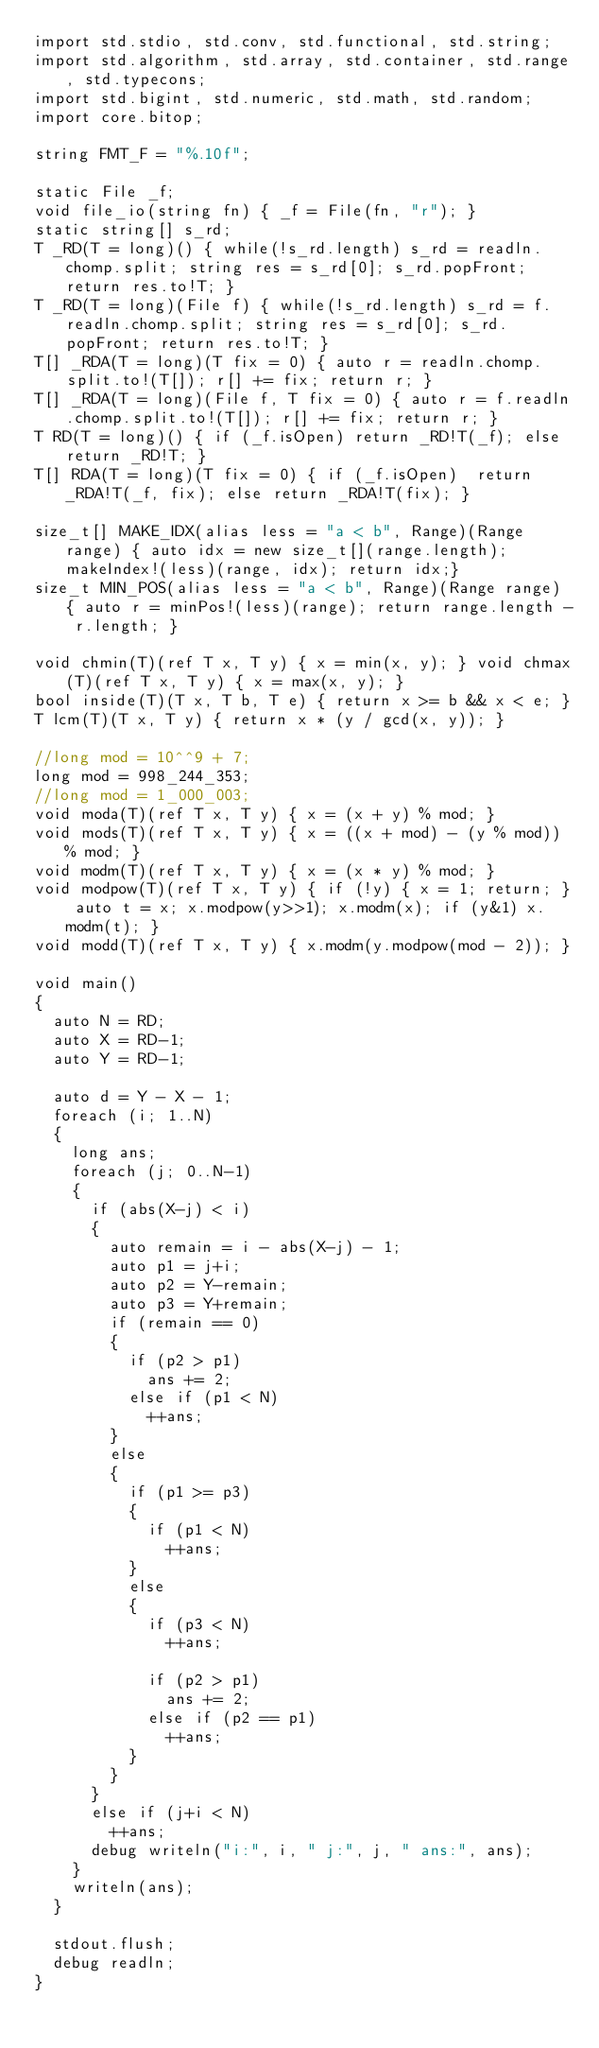Convert code to text. <code><loc_0><loc_0><loc_500><loc_500><_D_>import std.stdio, std.conv, std.functional, std.string;
import std.algorithm, std.array, std.container, std.range, std.typecons;
import std.bigint, std.numeric, std.math, std.random;
import core.bitop;

string FMT_F = "%.10f";

static File _f;
void file_io(string fn) { _f = File(fn, "r"); }
static string[] s_rd;
T _RD(T = long)() { while(!s_rd.length) s_rd = readln.chomp.split; string res = s_rd[0]; s_rd.popFront; return res.to!T; }
T _RD(T = long)(File f) { while(!s_rd.length) s_rd = f.readln.chomp.split; string res = s_rd[0]; s_rd.popFront; return res.to!T; }
T[] _RDA(T = long)(T fix = 0) { auto r = readln.chomp.split.to!(T[]); r[] += fix; return r; }
T[] _RDA(T = long)(File f, T fix = 0) { auto r = f.readln.chomp.split.to!(T[]); r[] += fix; return r; }
T RD(T = long)() { if (_f.isOpen) return _RD!T(_f); else return _RD!T; }
T[] RDA(T = long)(T fix = 0) { if (_f.isOpen)  return _RDA!T(_f, fix); else return _RDA!T(fix); }

size_t[] MAKE_IDX(alias less = "a < b", Range)(Range range) { auto idx = new size_t[](range.length); makeIndex!(less)(range, idx); return idx;}
size_t MIN_POS(alias less = "a < b", Range)(Range range) { auto r = minPos!(less)(range); return range.length - r.length; }

void chmin(T)(ref T x, T y) { x = min(x, y); } void chmax(T)(ref T x, T y) { x = max(x, y); }
bool inside(T)(T x, T b, T e) { return x >= b && x < e; }
T lcm(T)(T x, T y) { return x * (y / gcd(x, y)); }

//long mod = 10^^9 + 7;
long mod = 998_244_353;
//long mod = 1_000_003;
void moda(T)(ref T x, T y) { x = (x + y) % mod; }
void mods(T)(ref T x, T y) { x = ((x + mod) - (y % mod)) % mod; }
void modm(T)(ref T x, T y) { x = (x * y) % mod; }
void modpow(T)(ref T x, T y) { if (!y) { x = 1; return; } auto t = x; x.modpow(y>>1); x.modm(x); if (y&1) x.modm(t); }
void modd(T)(ref T x, T y) { x.modm(y.modpow(mod - 2)); }

void main()
{
	auto N = RD;
	auto X = RD-1;
	auto Y = RD-1;

	auto d = Y - X - 1;
	foreach (i; 1..N)
	{
		long ans;
		foreach (j; 0..N-1)
		{
			if (abs(X-j) < i)
			{
				auto remain = i - abs(X-j) - 1;
				auto p1 = j+i;
				auto p2 = Y-remain;
				auto p3 = Y+remain;
				if (remain == 0)
				{
					if (p2 > p1)
						ans += 2;
					else if (p1 < N)
						++ans;
				}
				else
				{
					if (p1 >= p3)
					{
						if (p1 < N)
							++ans;
					}
					else
					{
						if (p3 < N)
							++ans;

						if (p2 > p1)
							ans += 2;
						else if (p2 == p1)
							++ans;
					}
				}
			}
			else if (j+i < N)
				++ans;
			debug writeln("i:", i, " j:", j, " ans:", ans);
		}
		writeln(ans);
	}

	stdout.flush;
	debug readln;
}
</code> 